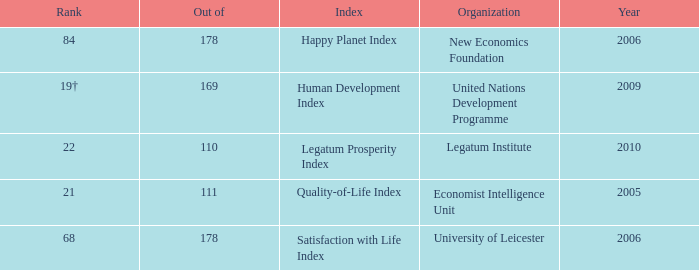What organization ranks 68? University of Leicester. 